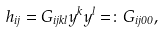<formula> <loc_0><loc_0><loc_500><loc_500>h _ { i j } = G _ { i j k l } y ^ { k } y ^ { l } = \colon G _ { i j 0 0 } ,</formula> 